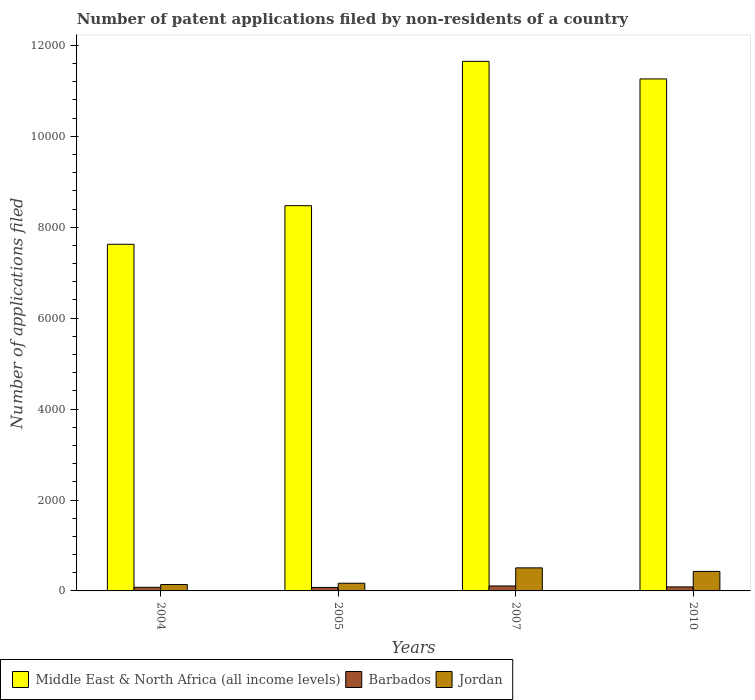How many groups of bars are there?
Keep it short and to the point. 4. Are the number of bars on each tick of the X-axis equal?
Offer a terse response. Yes. How many bars are there on the 4th tick from the left?
Ensure brevity in your answer.  3. How many bars are there on the 4th tick from the right?
Offer a very short reply. 3. What is the label of the 2nd group of bars from the left?
Provide a short and direct response. 2005. What is the number of applications filed in Middle East & North Africa (all income levels) in 2010?
Give a very brief answer. 1.13e+04. Across all years, what is the maximum number of applications filed in Middle East & North Africa (all income levels)?
Your answer should be compact. 1.16e+04. Across all years, what is the minimum number of applications filed in Middle East & North Africa (all income levels)?
Make the answer very short. 7626. What is the total number of applications filed in Middle East & North Africa (all income levels) in the graph?
Your answer should be compact. 3.90e+04. What is the difference between the number of applications filed in Barbados in 2007 and that in 2010?
Give a very brief answer. 21. What is the difference between the number of applications filed in Middle East & North Africa (all income levels) in 2010 and the number of applications filed in Barbados in 2004?
Offer a terse response. 1.12e+04. What is the average number of applications filed in Jordan per year?
Your response must be concise. 311.5. In the year 2004, what is the difference between the number of applications filed in Barbados and number of applications filed in Jordan?
Provide a short and direct response. -61. What is the ratio of the number of applications filed in Barbados in 2007 to that in 2010?
Provide a succinct answer. 1.24. Is the number of applications filed in Jordan in 2007 less than that in 2010?
Offer a terse response. No. What is the difference between the highest and the lowest number of applications filed in Jordan?
Keep it short and to the point. 366. Is the sum of the number of applications filed in Middle East & North Africa (all income levels) in 2007 and 2010 greater than the maximum number of applications filed in Jordan across all years?
Ensure brevity in your answer.  Yes. What does the 3rd bar from the left in 2004 represents?
Your answer should be very brief. Jordan. What does the 1st bar from the right in 2007 represents?
Your answer should be compact. Jordan. How many bars are there?
Provide a succinct answer. 12. How many years are there in the graph?
Offer a terse response. 4. What is the difference between two consecutive major ticks on the Y-axis?
Provide a succinct answer. 2000. Does the graph contain grids?
Your response must be concise. No. Where does the legend appear in the graph?
Ensure brevity in your answer.  Bottom left. How many legend labels are there?
Provide a succinct answer. 3. What is the title of the graph?
Offer a very short reply. Number of patent applications filed by non-residents of a country. Does "Cayman Islands" appear as one of the legend labels in the graph?
Make the answer very short. No. What is the label or title of the X-axis?
Ensure brevity in your answer.  Years. What is the label or title of the Y-axis?
Keep it short and to the point. Number of applications filed. What is the Number of applications filed of Middle East & North Africa (all income levels) in 2004?
Keep it short and to the point. 7626. What is the Number of applications filed of Barbados in 2004?
Provide a succinct answer. 80. What is the Number of applications filed in Jordan in 2004?
Provide a short and direct response. 141. What is the Number of applications filed of Middle East & North Africa (all income levels) in 2005?
Offer a very short reply. 8475. What is the Number of applications filed of Jordan in 2005?
Your response must be concise. 169. What is the Number of applications filed of Middle East & North Africa (all income levels) in 2007?
Your answer should be very brief. 1.16e+04. What is the Number of applications filed in Barbados in 2007?
Provide a succinct answer. 109. What is the Number of applications filed in Jordan in 2007?
Your answer should be very brief. 507. What is the Number of applications filed in Middle East & North Africa (all income levels) in 2010?
Keep it short and to the point. 1.13e+04. What is the Number of applications filed of Jordan in 2010?
Your answer should be very brief. 429. Across all years, what is the maximum Number of applications filed of Middle East & North Africa (all income levels)?
Offer a terse response. 1.16e+04. Across all years, what is the maximum Number of applications filed of Barbados?
Provide a succinct answer. 109. Across all years, what is the maximum Number of applications filed in Jordan?
Make the answer very short. 507. Across all years, what is the minimum Number of applications filed of Middle East & North Africa (all income levels)?
Provide a succinct answer. 7626. Across all years, what is the minimum Number of applications filed in Jordan?
Your response must be concise. 141. What is the total Number of applications filed in Middle East & North Africa (all income levels) in the graph?
Provide a short and direct response. 3.90e+04. What is the total Number of applications filed in Barbados in the graph?
Provide a short and direct response. 353. What is the total Number of applications filed of Jordan in the graph?
Your answer should be very brief. 1246. What is the difference between the Number of applications filed in Middle East & North Africa (all income levels) in 2004 and that in 2005?
Ensure brevity in your answer.  -849. What is the difference between the Number of applications filed in Barbados in 2004 and that in 2005?
Give a very brief answer. 4. What is the difference between the Number of applications filed of Middle East & North Africa (all income levels) in 2004 and that in 2007?
Offer a very short reply. -4024. What is the difference between the Number of applications filed of Jordan in 2004 and that in 2007?
Offer a terse response. -366. What is the difference between the Number of applications filed in Middle East & North Africa (all income levels) in 2004 and that in 2010?
Your response must be concise. -3637. What is the difference between the Number of applications filed in Jordan in 2004 and that in 2010?
Give a very brief answer. -288. What is the difference between the Number of applications filed of Middle East & North Africa (all income levels) in 2005 and that in 2007?
Make the answer very short. -3175. What is the difference between the Number of applications filed in Barbados in 2005 and that in 2007?
Your answer should be very brief. -33. What is the difference between the Number of applications filed in Jordan in 2005 and that in 2007?
Your answer should be very brief. -338. What is the difference between the Number of applications filed of Middle East & North Africa (all income levels) in 2005 and that in 2010?
Offer a terse response. -2788. What is the difference between the Number of applications filed of Barbados in 2005 and that in 2010?
Your answer should be very brief. -12. What is the difference between the Number of applications filed in Jordan in 2005 and that in 2010?
Offer a terse response. -260. What is the difference between the Number of applications filed in Middle East & North Africa (all income levels) in 2007 and that in 2010?
Provide a short and direct response. 387. What is the difference between the Number of applications filed in Barbados in 2007 and that in 2010?
Keep it short and to the point. 21. What is the difference between the Number of applications filed in Middle East & North Africa (all income levels) in 2004 and the Number of applications filed in Barbados in 2005?
Offer a very short reply. 7550. What is the difference between the Number of applications filed in Middle East & North Africa (all income levels) in 2004 and the Number of applications filed in Jordan in 2005?
Your answer should be very brief. 7457. What is the difference between the Number of applications filed in Barbados in 2004 and the Number of applications filed in Jordan in 2005?
Ensure brevity in your answer.  -89. What is the difference between the Number of applications filed in Middle East & North Africa (all income levels) in 2004 and the Number of applications filed in Barbados in 2007?
Offer a terse response. 7517. What is the difference between the Number of applications filed of Middle East & North Africa (all income levels) in 2004 and the Number of applications filed of Jordan in 2007?
Offer a very short reply. 7119. What is the difference between the Number of applications filed in Barbados in 2004 and the Number of applications filed in Jordan in 2007?
Make the answer very short. -427. What is the difference between the Number of applications filed of Middle East & North Africa (all income levels) in 2004 and the Number of applications filed of Barbados in 2010?
Give a very brief answer. 7538. What is the difference between the Number of applications filed of Middle East & North Africa (all income levels) in 2004 and the Number of applications filed of Jordan in 2010?
Keep it short and to the point. 7197. What is the difference between the Number of applications filed of Barbados in 2004 and the Number of applications filed of Jordan in 2010?
Ensure brevity in your answer.  -349. What is the difference between the Number of applications filed in Middle East & North Africa (all income levels) in 2005 and the Number of applications filed in Barbados in 2007?
Your answer should be compact. 8366. What is the difference between the Number of applications filed of Middle East & North Africa (all income levels) in 2005 and the Number of applications filed of Jordan in 2007?
Ensure brevity in your answer.  7968. What is the difference between the Number of applications filed of Barbados in 2005 and the Number of applications filed of Jordan in 2007?
Give a very brief answer. -431. What is the difference between the Number of applications filed in Middle East & North Africa (all income levels) in 2005 and the Number of applications filed in Barbados in 2010?
Your response must be concise. 8387. What is the difference between the Number of applications filed in Middle East & North Africa (all income levels) in 2005 and the Number of applications filed in Jordan in 2010?
Provide a succinct answer. 8046. What is the difference between the Number of applications filed of Barbados in 2005 and the Number of applications filed of Jordan in 2010?
Offer a terse response. -353. What is the difference between the Number of applications filed in Middle East & North Africa (all income levels) in 2007 and the Number of applications filed in Barbados in 2010?
Your response must be concise. 1.16e+04. What is the difference between the Number of applications filed of Middle East & North Africa (all income levels) in 2007 and the Number of applications filed of Jordan in 2010?
Ensure brevity in your answer.  1.12e+04. What is the difference between the Number of applications filed in Barbados in 2007 and the Number of applications filed in Jordan in 2010?
Offer a terse response. -320. What is the average Number of applications filed of Middle East & North Africa (all income levels) per year?
Provide a succinct answer. 9753.5. What is the average Number of applications filed of Barbados per year?
Provide a short and direct response. 88.25. What is the average Number of applications filed of Jordan per year?
Offer a terse response. 311.5. In the year 2004, what is the difference between the Number of applications filed of Middle East & North Africa (all income levels) and Number of applications filed of Barbados?
Give a very brief answer. 7546. In the year 2004, what is the difference between the Number of applications filed in Middle East & North Africa (all income levels) and Number of applications filed in Jordan?
Ensure brevity in your answer.  7485. In the year 2004, what is the difference between the Number of applications filed in Barbados and Number of applications filed in Jordan?
Give a very brief answer. -61. In the year 2005, what is the difference between the Number of applications filed in Middle East & North Africa (all income levels) and Number of applications filed in Barbados?
Your response must be concise. 8399. In the year 2005, what is the difference between the Number of applications filed of Middle East & North Africa (all income levels) and Number of applications filed of Jordan?
Your answer should be very brief. 8306. In the year 2005, what is the difference between the Number of applications filed in Barbados and Number of applications filed in Jordan?
Ensure brevity in your answer.  -93. In the year 2007, what is the difference between the Number of applications filed in Middle East & North Africa (all income levels) and Number of applications filed in Barbados?
Offer a terse response. 1.15e+04. In the year 2007, what is the difference between the Number of applications filed in Middle East & North Africa (all income levels) and Number of applications filed in Jordan?
Keep it short and to the point. 1.11e+04. In the year 2007, what is the difference between the Number of applications filed in Barbados and Number of applications filed in Jordan?
Keep it short and to the point. -398. In the year 2010, what is the difference between the Number of applications filed in Middle East & North Africa (all income levels) and Number of applications filed in Barbados?
Offer a terse response. 1.12e+04. In the year 2010, what is the difference between the Number of applications filed of Middle East & North Africa (all income levels) and Number of applications filed of Jordan?
Your answer should be compact. 1.08e+04. In the year 2010, what is the difference between the Number of applications filed in Barbados and Number of applications filed in Jordan?
Keep it short and to the point. -341. What is the ratio of the Number of applications filed in Middle East & North Africa (all income levels) in 2004 to that in 2005?
Ensure brevity in your answer.  0.9. What is the ratio of the Number of applications filed of Barbados in 2004 to that in 2005?
Give a very brief answer. 1.05. What is the ratio of the Number of applications filed in Jordan in 2004 to that in 2005?
Your response must be concise. 0.83. What is the ratio of the Number of applications filed in Middle East & North Africa (all income levels) in 2004 to that in 2007?
Your response must be concise. 0.65. What is the ratio of the Number of applications filed of Barbados in 2004 to that in 2007?
Your answer should be very brief. 0.73. What is the ratio of the Number of applications filed in Jordan in 2004 to that in 2007?
Offer a terse response. 0.28. What is the ratio of the Number of applications filed in Middle East & North Africa (all income levels) in 2004 to that in 2010?
Offer a very short reply. 0.68. What is the ratio of the Number of applications filed in Barbados in 2004 to that in 2010?
Offer a terse response. 0.91. What is the ratio of the Number of applications filed of Jordan in 2004 to that in 2010?
Your answer should be compact. 0.33. What is the ratio of the Number of applications filed of Middle East & North Africa (all income levels) in 2005 to that in 2007?
Give a very brief answer. 0.73. What is the ratio of the Number of applications filed of Barbados in 2005 to that in 2007?
Make the answer very short. 0.7. What is the ratio of the Number of applications filed of Middle East & North Africa (all income levels) in 2005 to that in 2010?
Your response must be concise. 0.75. What is the ratio of the Number of applications filed of Barbados in 2005 to that in 2010?
Your response must be concise. 0.86. What is the ratio of the Number of applications filed in Jordan in 2005 to that in 2010?
Offer a very short reply. 0.39. What is the ratio of the Number of applications filed of Middle East & North Africa (all income levels) in 2007 to that in 2010?
Your answer should be very brief. 1.03. What is the ratio of the Number of applications filed in Barbados in 2007 to that in 2010?
Give a very brief answer. 1.24. What is the ratio of the Number of applications filed of Jordan in 2007 to that in 2010?
Make the answer very short. 1.18. What is the difference between the highest and the second highest Number of applications filed in Middle East & North Africa (all income levels)?
Provide a succinct answer. 387. What is the difference between the highest and the second highest Number of applications filed of Barbados?
Your answer should be compact. 21. What is the difference between the highest and the second highest Number of applications filed of Jordan?
Offer a terse response. 78. What is the difference between the highest and the lowest Number of applications filed of Middle East & North Africa (all income levels)?
Provide a succinct answer. 4024. What is the difference between the highest and the lowest Number of applications filed in Barbados?
Provide a succinct answer. 33. What is the difference between the highest and the lowest Number of applications filed of Jordan?
Give a very brief answer. 366. 